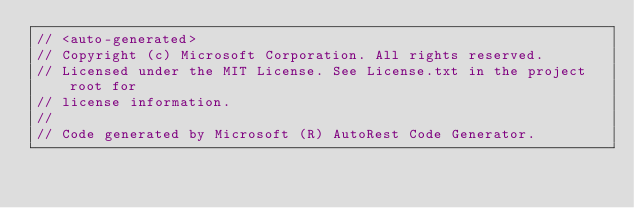<code> <loc_0><loc_0><loc_500><loc_500><_C#_>// <auto-generated>
// Copyright (c) Microsoft Corporation. All rights reserved.
// Licensed under the MIT License. See License.txt in the project root for
// license information.
//
// Code generated by Microsoft (R) AutoRest Code Generator.</code> 